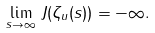Convert formula to latex. <formula><loc_0><loc_0><loc_500><loc_500>\lim _ { s \to \infty } \, J ( \zeta _ { u } ( s ) ) = - \infty .</formula> 